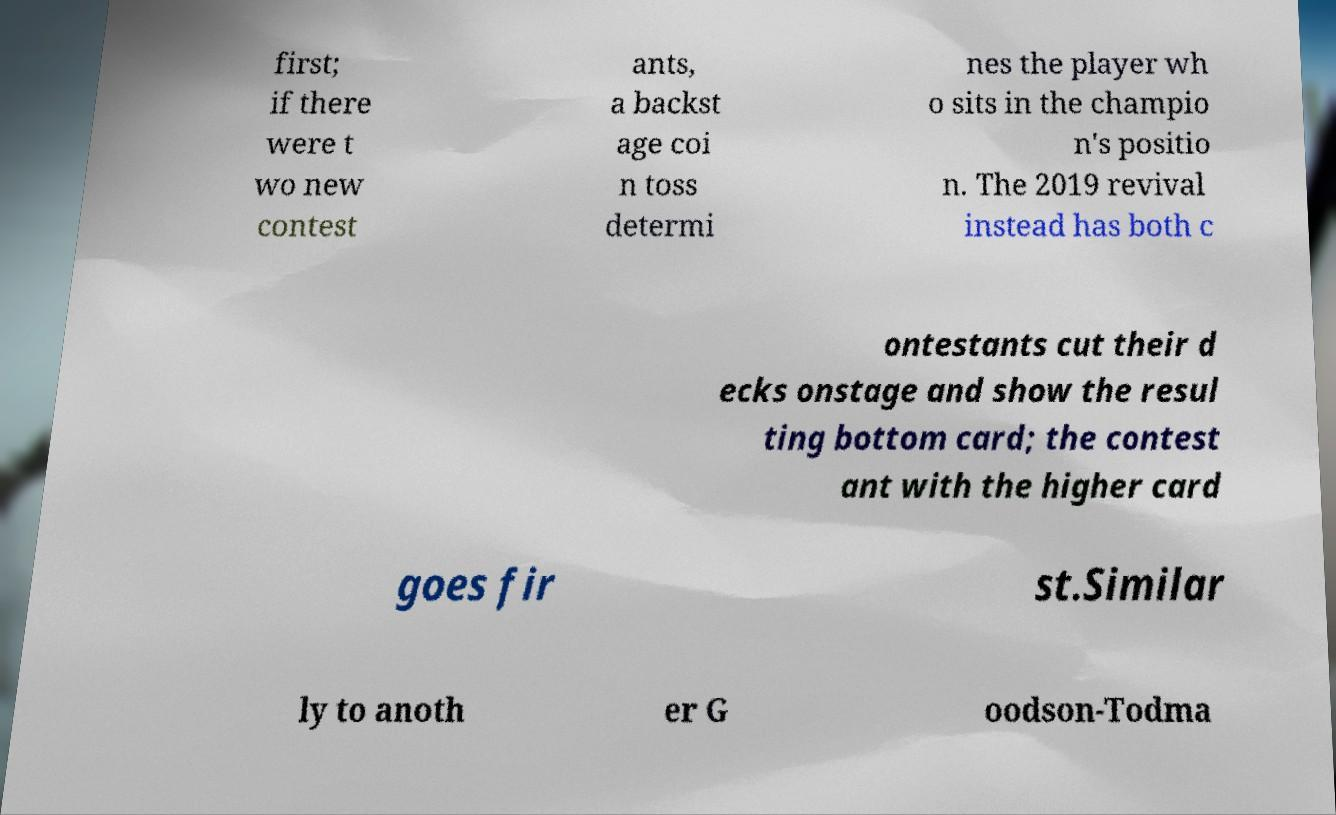Please read and relay the text visible in this image. What does it say? first; if there were t wo new contest ants, a backst age coi n toss determi nes the player wh o sits in the champio n's positio n. The 2019 revival instead has both c ontestants cut their d ecks onstage and show the resul ting bottom card; the contest ant with the higher card goes fir st.Similar ly to anoth er G oodson-Todma 